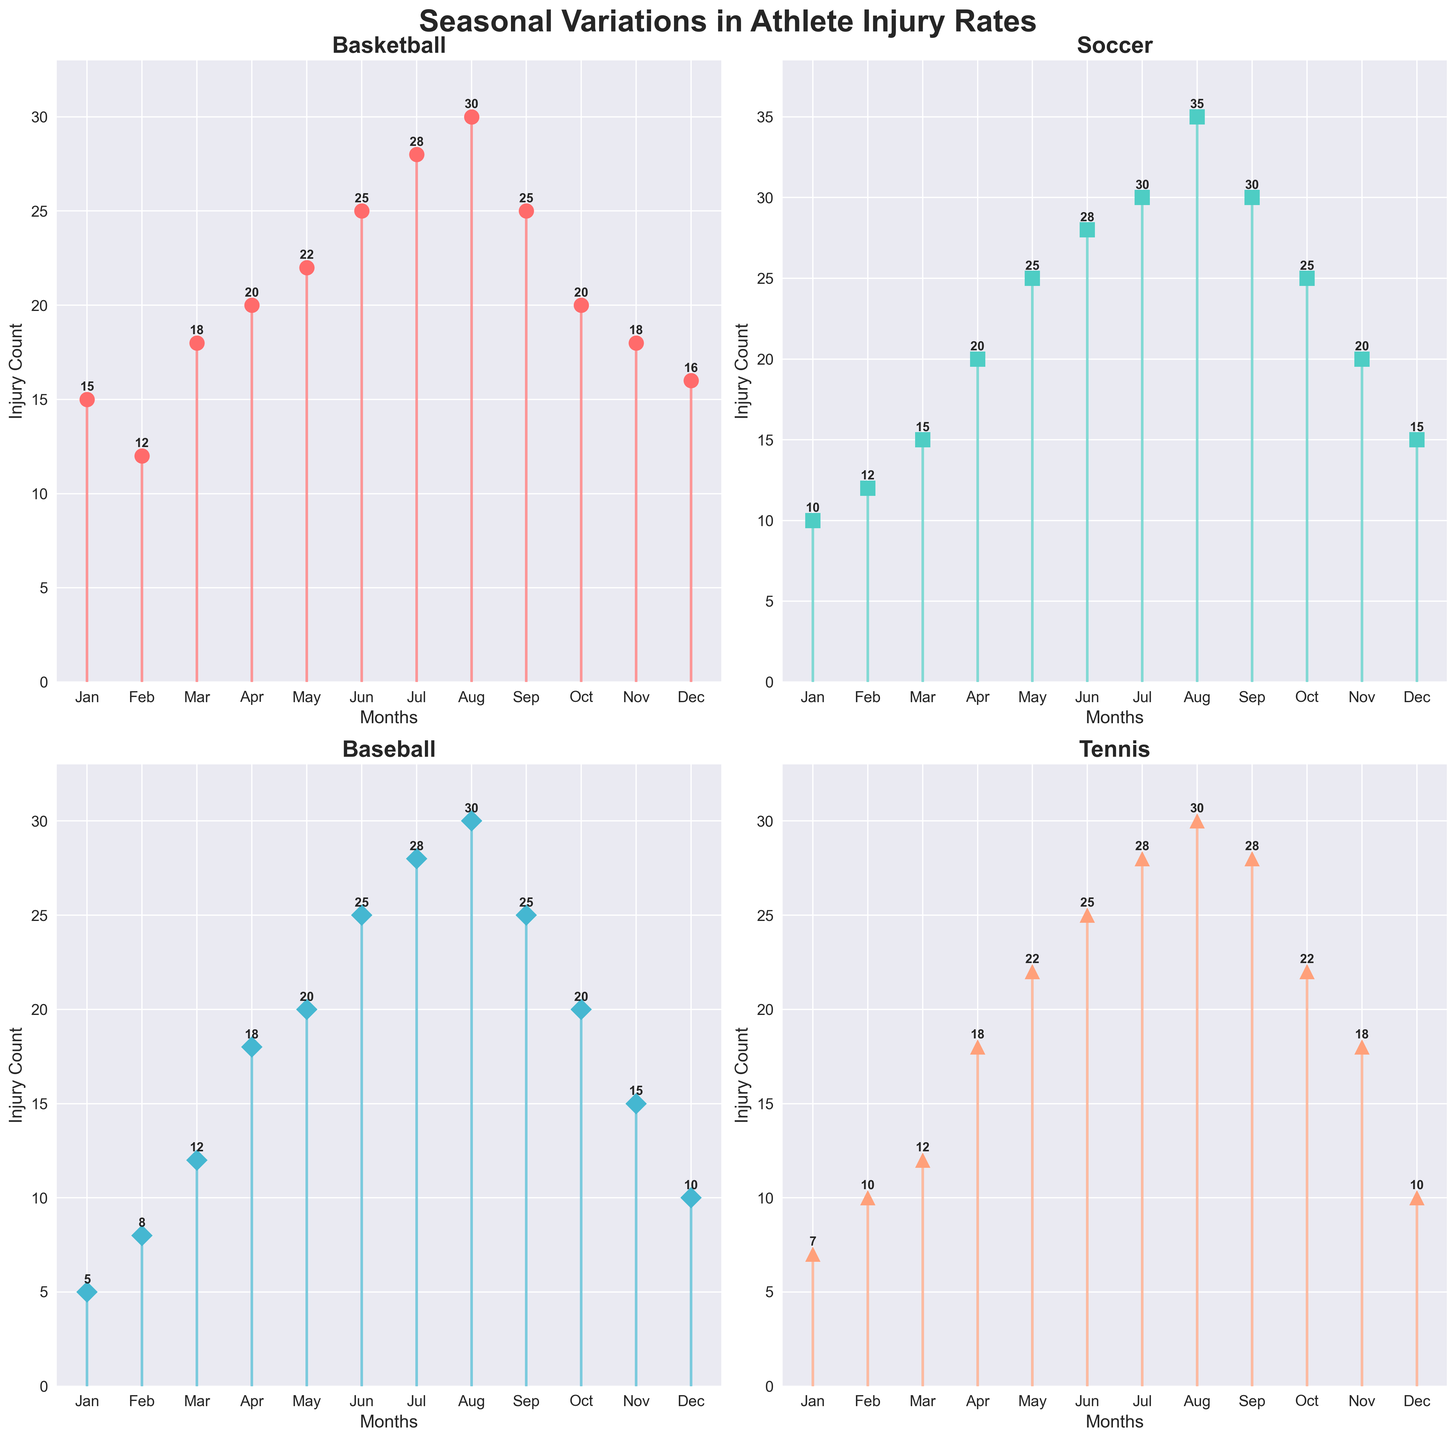What is the title of the figure? The title is displayed at the top of the figure, stating the overall theme or subject of the visualized data. Here, the title is "Seasonal Variations in Athlete Injury Rates".
Answer: Seasonal Variations in Athlete Injury Rates How many subplots are there in the figure? By observing the layout of the figure, we can see that there are 2 rows and 2 columns of subplots, making a total of 4 subplots.
Answer: 4 In which month do injury rates peak for soccer? By looking at the soccer subplot and observing the highest point on the stem plot, we can see that the injury rates peak in August.
Answer: August Which sport has the least injury counts in January? Observing the subplots for the month of January, Baseball has the lowest injury count with only 5 injuries.
Answer: Baseball What is the total number of injuries in June across all sports? Sum the injuries for June from all four sports: (25 for Basketball) + (28 for Soccer) + (25 for Baseball) + (25 for Tennis) = 103.
Answer: 103 Which sport has the most fluctuating injury rate throughout the year? To determine the sport with the most fluctuation, look for the one with the widest range between its minimum and maximum injury counts. Soccer ranges from 10 (January) to 35 (August), making it the sport with the most fluctuating injury rate.
Answer: Soccer In which months is the injury rate for basketball consistent around 20? By viewing the basketball subplot, the injury rate is around 20 in April (20 injuries) and October (20 injuries).
Answer: April and October Calculate the average number of injuries for tennis in the first quarter of the year (January, February, March). Sum the injuries for January, February, and March for Tennis: (7 + 10 + 12) = 29, then divide by 3. The average is 29/3 ≈ 9.67.
Answer: 9.67 Which month has the second highest injury count for baseball? Observing the baseball subplot, June (25 injuries) has the second highest injury count, only less than August (30 injuries).
Answer: June How does the trend in injury rates for basketball compare to tennis from July to September? Comparing the subplots, both Basketball and Tennis have a steady increase from July (Basketball: 28, Tennis: 28), peak in August (Basketball: 30, Tennis: 30), and then have a slight decrease in September (Basketball: 25, Tennis: 28). The trends for both sports are similar in this period.
Answer: Similar trends 